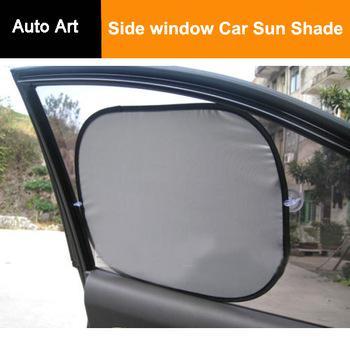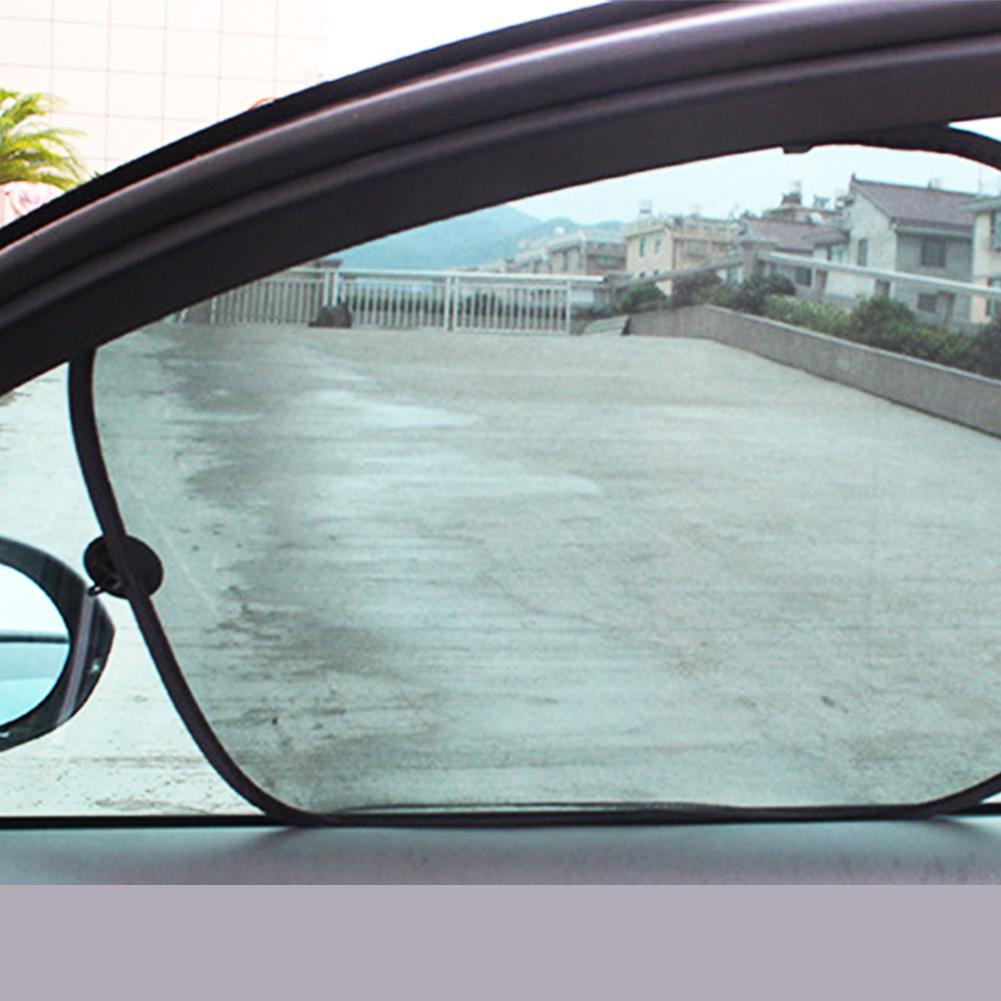The first image is the image on the left, the second image is the image on the right. Assess this claim about the two images: "In at last one image, a person's hand is shown extending a car window shade.". Correct or not? Answer yes or no. No. 